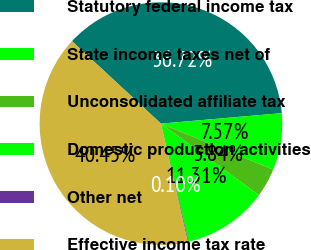<chart> <loc_0><loc_0><loc_500><loc_500><pie_chart><fcel>Statutory federal income tax<fcel>State income taxes net of<fcel>Unconsolidated affiliate tax<fcel>Domestic production activities<fcel>Other net<fcel>Effective income tax rate<nl><fcel>36.72%<fcel>7.57%<fcel>3.84%<fcel>11.31%<fcel>0.1%<fcel>40.45%<nl></chart> 